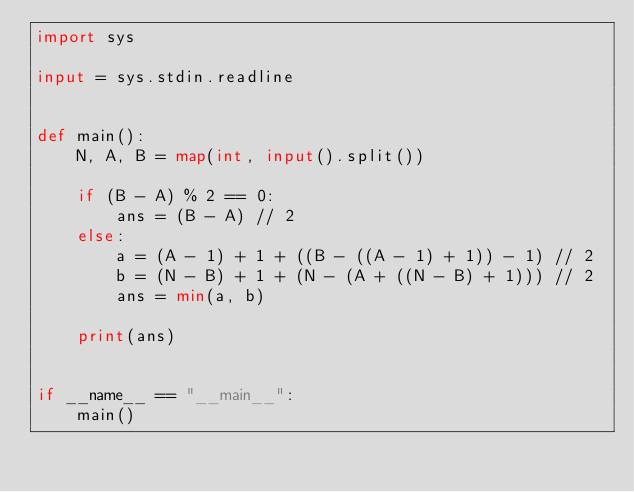Convert code to text. <code><loc_0><loc_0><loc_500><loc_500><_Python_>import sys

input = sys.stdin.readline


def main():
    N, A, B = map(int, input().split())

    if (B - A) % 2 == 0:
        ans = (B - A) // 2
    else:
        a = (A - 1) + 1 + ((B - ((A - 1) + 1)) - 1) // 2
        b = (N - B) + 1 + (N - (A + ((N - B) + 1))) // 2
        ans = min(a, b)

    print(ans)


if __name__ == "__main__":
    main()
</code> 